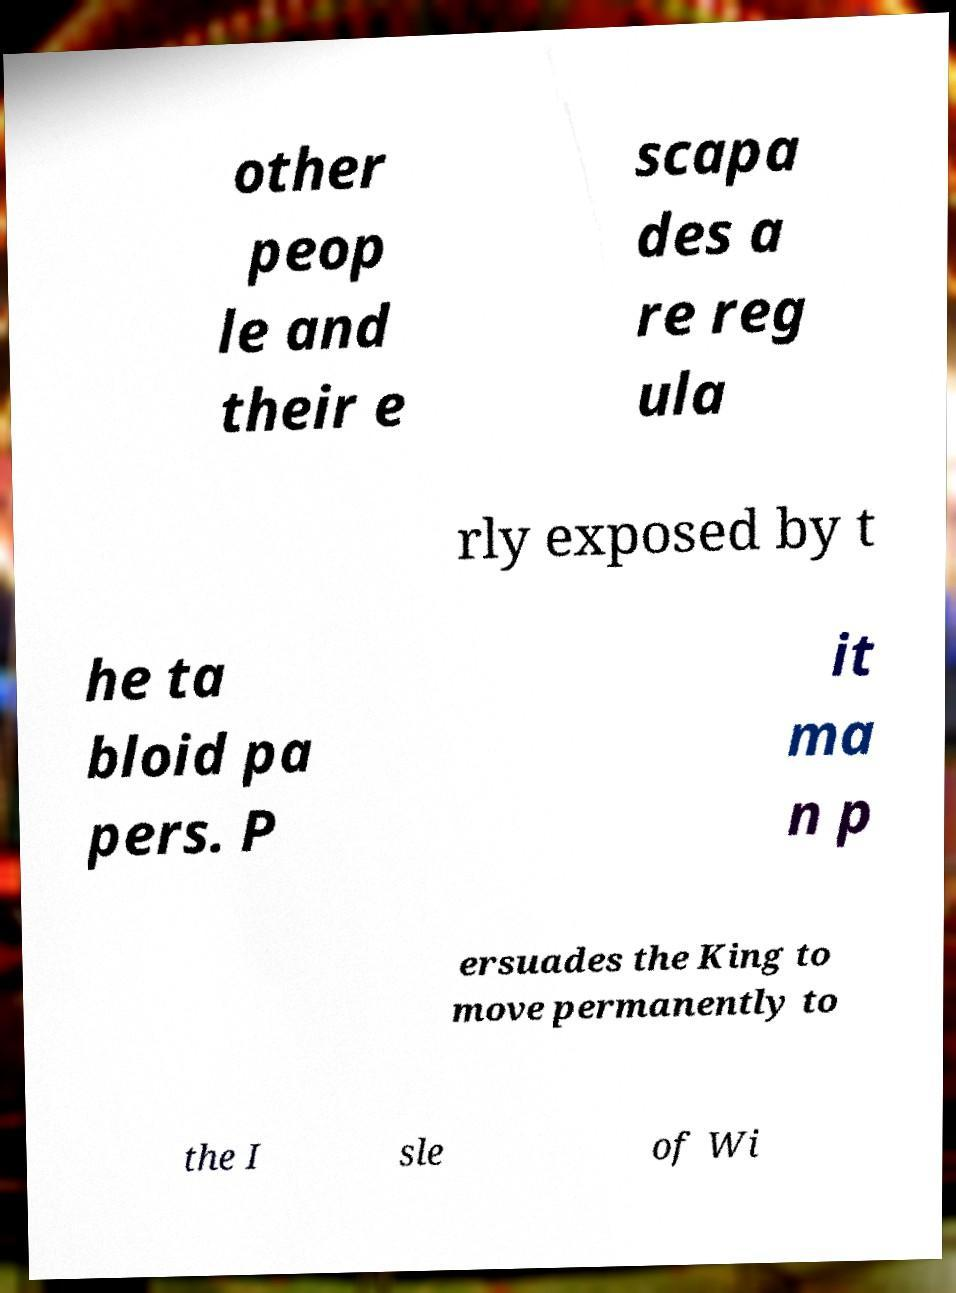Could you assist in decoding the text presented in this image and type it out clearly? other peop le and their e scapa des a re reg ula rly exposed by t he ta bloid pa pers. P it ma n p ersuades the King to move permanently to the I sle of Wi 